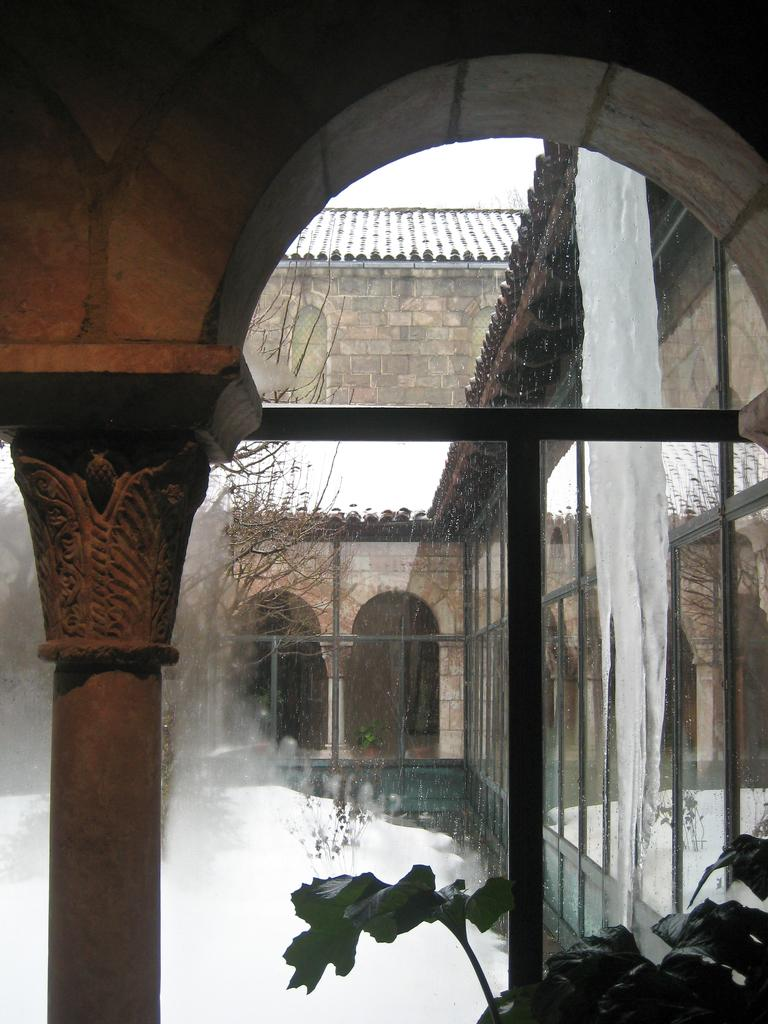What type of structure is present in the image? There is a building in the image. Where is the tree located in the image? The tree is on the left side of the image. What type of vegetation is present in the bottom right corner of the image? There is a plant in the bottom right corner of the image. What is the weather like in the image? Snow is visible in the image, indicating a cold or wintry weather condition. What can be seen in the background of the image? The sky is visible in the image. What type of lumber is being used to construct the building in the image? There is no information about the type of lumber used to construct the building in the image. Can you tell me how many brothers are visible in the image? There are no people, including brothers, present in the image. 